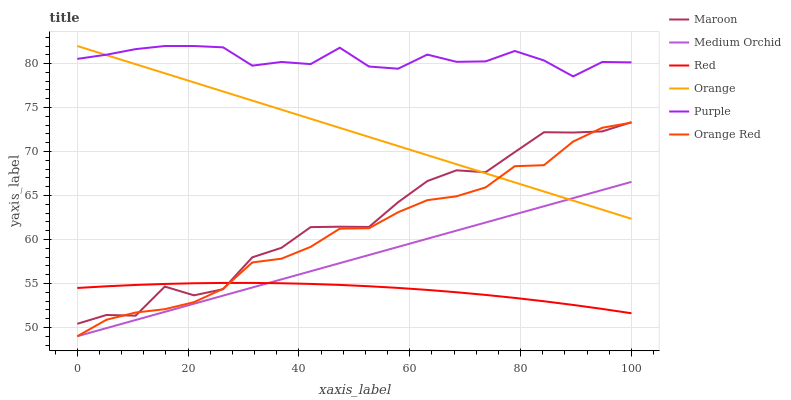Does Red have the minimum area under the curve?
Answer yes or no. Yes. Does Purple have the maximum area under the curve?
Answer yes or no. Yes. Does Medium Orchid have the minimum area under the curve?
Answer yes or no. No. Does Medium Orchid have the maximum area under the curve?
Answer yes or no. No. Is Medium Orchid the smoothest?
Answer yes or no. Yes. Is Maroon the roughest?
Answer yes or no. Yes. Is Maroon the smoothest?
Answer yes or no. No. Is Medium Orchid the roughest?
Answer yes or no. No. Does Medium Orchid have the lowest value?
Answer yes or no. Yes. Does Maroon have the lowest value?
Answer yes or no. No. Does Orange have the highest value?
Answer yes or no. Yes. Does Medium Orchid have the highest value?
Answer yes or no. No. Is Medium Orchid less than Maroon?
Answer yes or no. Yes. Is Purple greater than Medium Orchid?
Answer yes or no. Yes. Does Orange Red intersect Orange?
Answer yes or no. Yes. Is Orange Red less than Orange?
Answer yes or no. No. Is Orange Red greater than Orange?
Answer yes or no. No. Does Medium Orchid intersect Maroon?
Answer yes or no. No. 